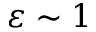<formula> <loc_0><loc_0><loc_500><loc_500>\varepsilon \sim 1</formula> 